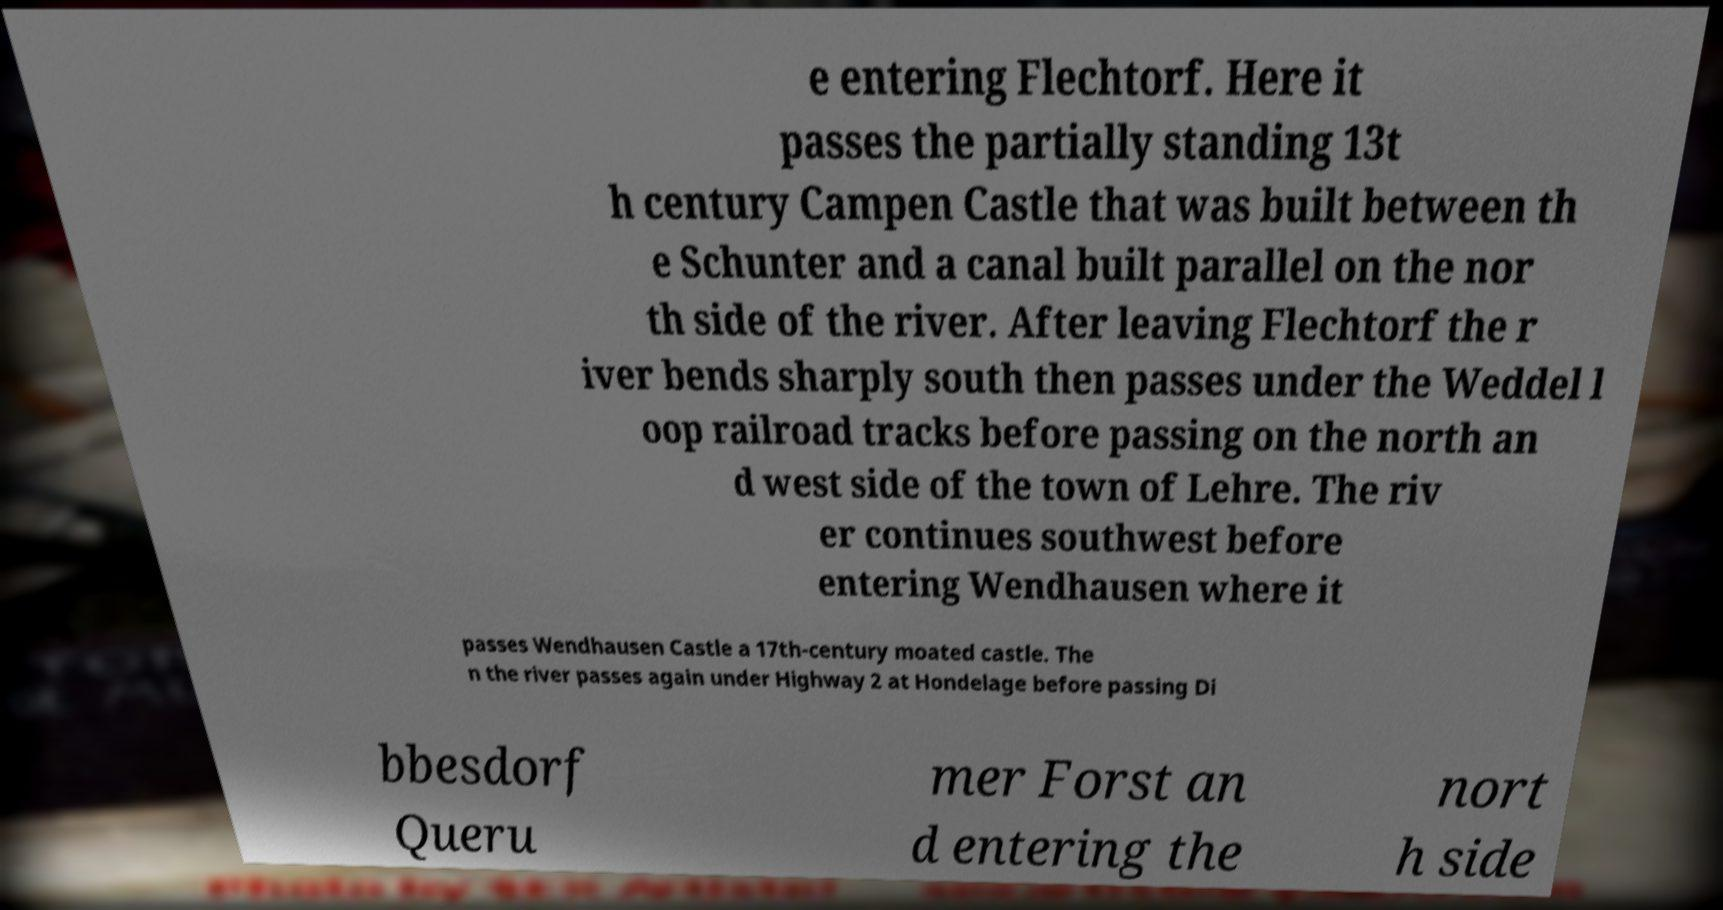Can you accurately transcribe the text from the provided image for me? e entering Flechtorf. Here it passes the partially standing 13t h century Campen Castle that was built between th e Schunter and a canal built parallel on the nor th side of the river. After leaving Flechtorf the r iver bends sharply south then passes under the Weddel l oop railroad tracks before passing on the north an d west side of the town of Lehre. The riv er continues southwest before entering Wendhausen where it passes Wendhausen Castle a 17th-century moated castle. The n the river passes again under Highway 2 at Hondelage before passing Di bbesdorf Queru mer Forst an d entering the nort h side 